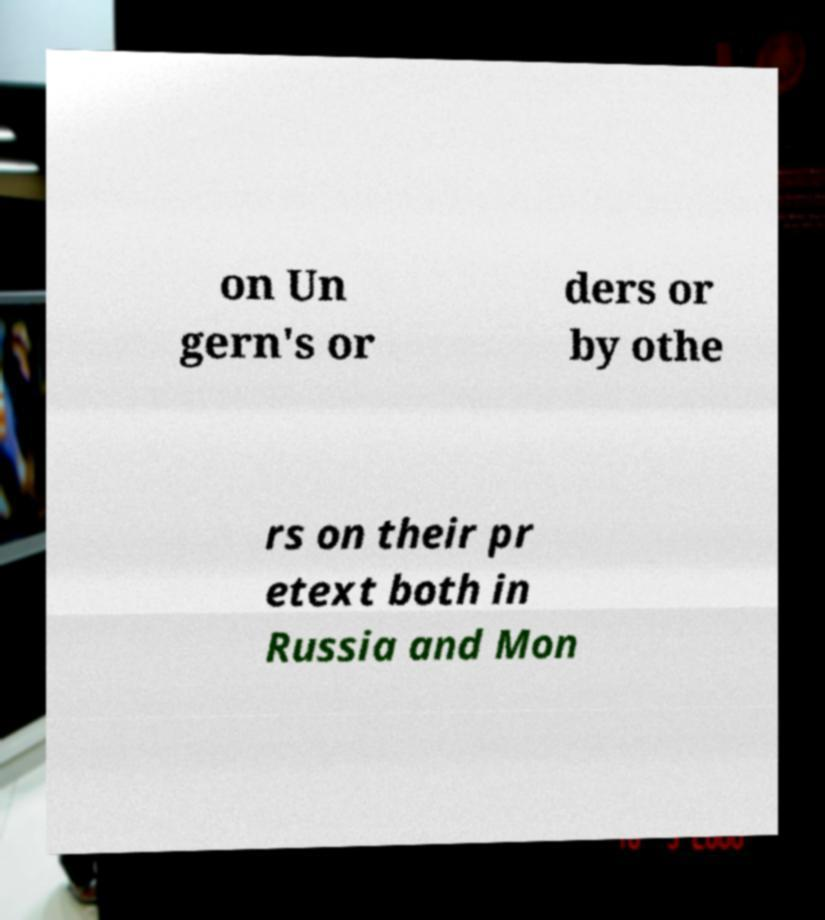There's text embedded in this image that I need extracted. Can you transcribe it verbatim? on Un gern's or ders or by othe rs on their pr etext both in Russia and Mon 